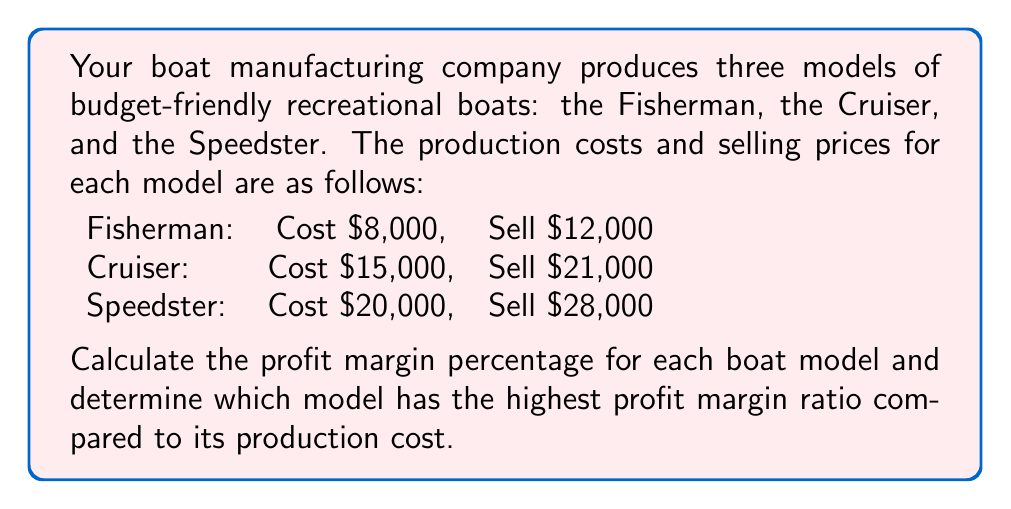Could you help me with this problem? To solve this problem, we'll follow these steps:

1. Calculate the profit for each boat model
2. Calculate the profit margin percentage for each model
3. Calculate the profit margin ratio for each model
4. Compare the ratios to determine which is highest

Step 1: Calculate the profit for each boat model
Profit = Selling Price - Production Cost

Fisherman: $12,000 - $8,000 = $4,000
Cruiser: $21,000 - $15,000 = $6,000
Speedster: $28,000 - $20,000 = $8,000

Step 2: Calculate the profit margin percentage for each model
Profit Margin Percentage = (Profit / Selling Price) × 100%

Fisherman: $$(4,000 / 12,000) \times 100\% = 33.33\%$$
Cruiser: $$(6,000 / 21,000) \times 100\% = 28.57\%$$
Speedster: $$(8,000 / 28,000) \times 100\% = 28.57\%$$

Step 3: Calculate the profit margin ratio for each model
Profit Margin Ratio = Profit / Production Cost

Fisherman: $$4,000 / 8,000 = 0.5$$
Cruiser: $$6,000 / 15,000 = 0.4$$
Speedster: $$8,000 / 20,000 = 0.4$$

Step 4: Compare the ratios
The Fisherman model has the highest profit margin ratio at 0.5, compared to 0.4 for both the Cruiser and Speedster models.
Answer: Profit margin percentages:
Fisherman: 33.33%
Cruiser: 28.57%
Speedster: 28.57%

The Fisherman model has the highest profit margin ratio (0.5) compared to its production cost. 